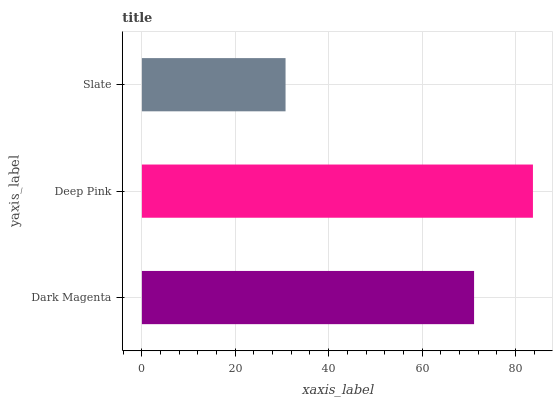Is Slate the minimum?
Answer yes or no. Yes. Is Deep Pink the maximum?
Answer yes or no. Yes. Is Deep Pink the minimum?
Answer yes or no. No. Is Slate the maximum?
Answer yes or no. No. Is Deep Pink greater than Slate?
Answer yes or no. Yes. Is Slate less than Deep Pink?
Answer yes or no. Yes. Is Slate greater than Deep Pink?
Answer yes or no. No. Is Deep Pink less than Slate?
Answer yes or no. No. Is Dark Magenta the high median?
Answer yes or no. Yes. Is Dark Magenta the low median?
Answer yes or no. Yes. Is Slate the high median?
Answer yes or no. No. Is Deep Pink the low median?
Answer yes or no. No. 